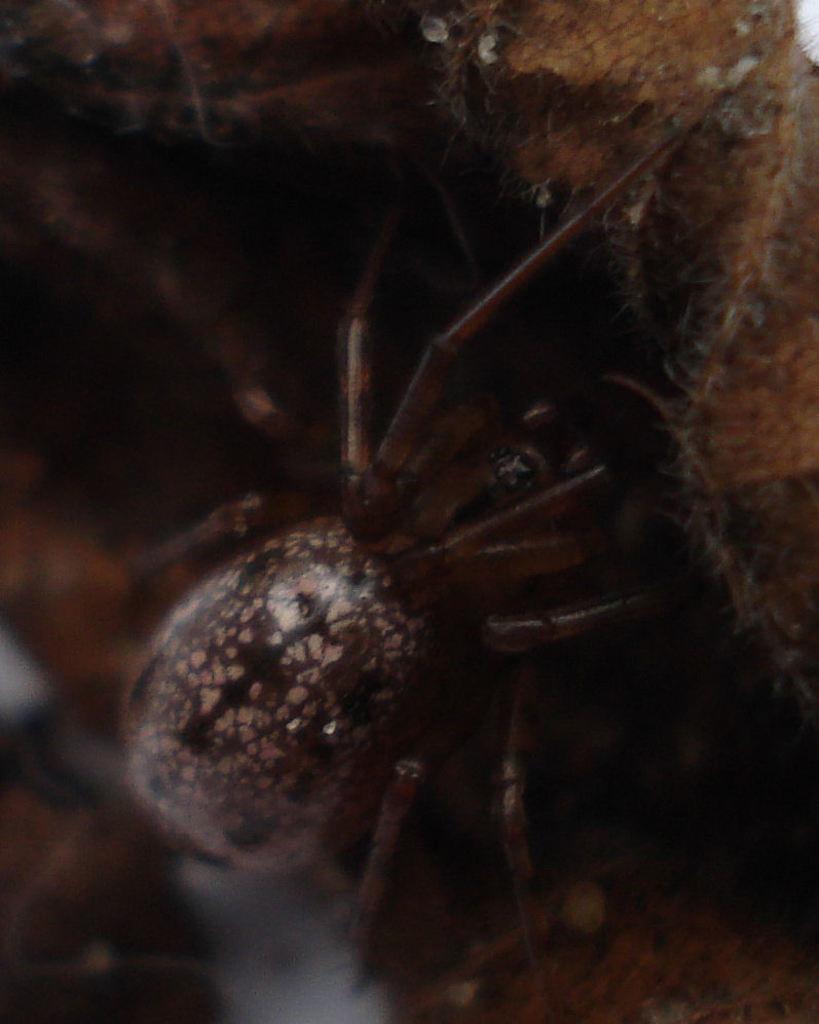Can you describe this image briefly? In the center of the image, we can see an insect and there is a rock. 